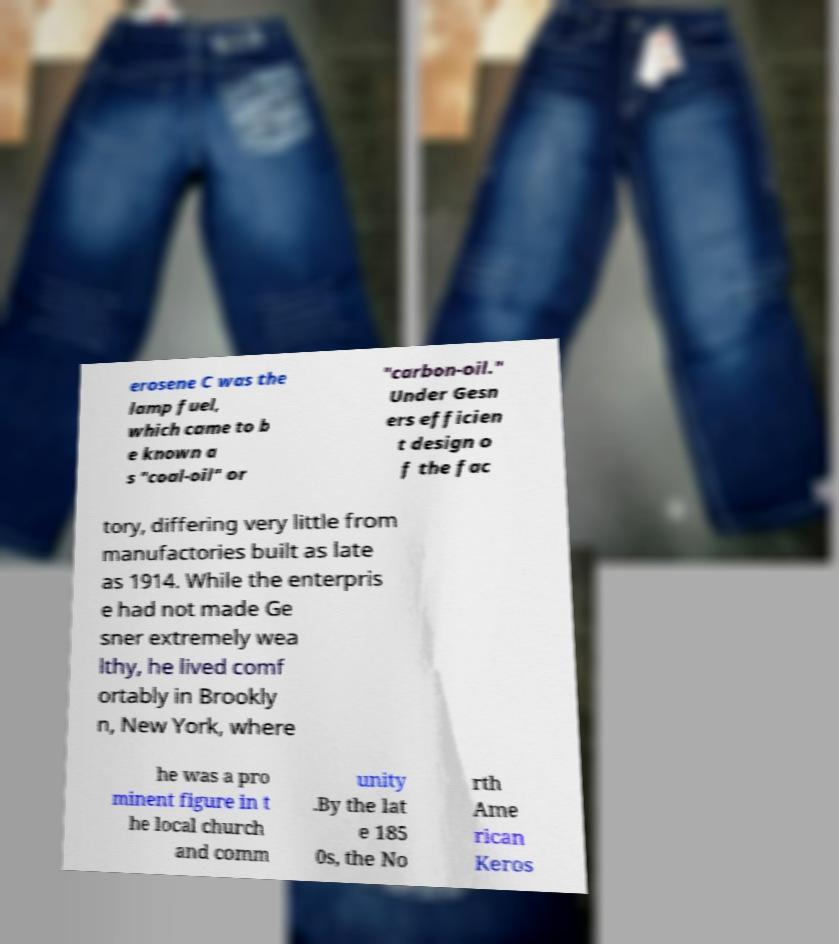Please identify and transcribe the text found in this image. erosene C was the lamp fuel, which came to b e known a s "coal-oil" or "carbon-oil." Under Gesn ers efficien t design o f the fac tory, differing very little from manufactories built as late as 1914. While the enterpris e had not made Ge sner extremely wea lthy, he lived comf ortably in Brookly n, New York, where he was a pro minent figure in t he local church and comm unity .By the lat e 185 0s, the No rth Ame rican Keros 